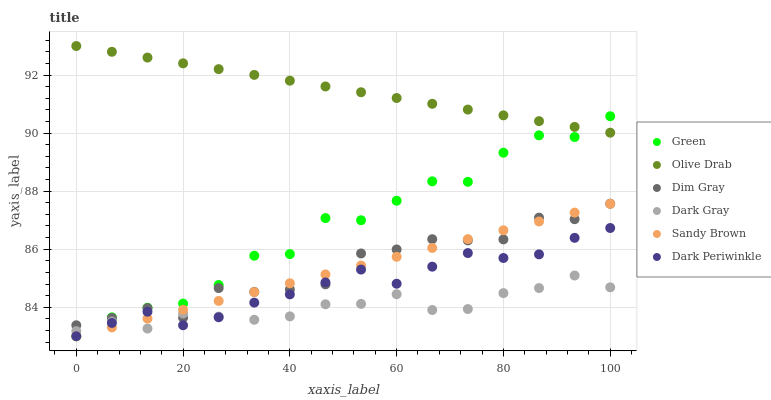Does Dark Gray have the minimum area under the curve?
Answer yes or no. Yes. Does Olive Drab have the maximum area under the curve?
Answer yes or no. Yes. Does Green have the minimum area under the curve?
Answer yes or no. No. Does Green have the maximum area under the curve?
Answer yes or no. No. Is Sandy Brown the smoothest?
Answer yes or no. Yes. Is Green the roughest?
Answer yes or no. Yes. Is Dark Gray the smoothest?
Answer yes or no. No. Is Dark Gray the roughest?
Answer yes or no. No. Does Green have the lowest value?
Answer yes or no. Yes. Does Dark Gray have the lowest value?
Answer yes or no. No. Does Olive Drab have the highest value?
Answer yes or no. Yes. Does Green have the highest value?
Answer yes or no. No. Is Dark Gray less than Olive Drab?
Answer yes or no. Yes. Is Olive Drab greater than Sandy Brown?
Answer yes or no. Yes. Does Dim Gray intersect Sandy Brown?
Answer yes or no. Yes. Is Dim Gray less than Sandy Brown?
Answer yes or no. No. Is Dim Gray greater than Sandy Brown?
Answer yes or no. No. Does Dark Gray intersect Olive Drab?
Answer yes or no. No. 